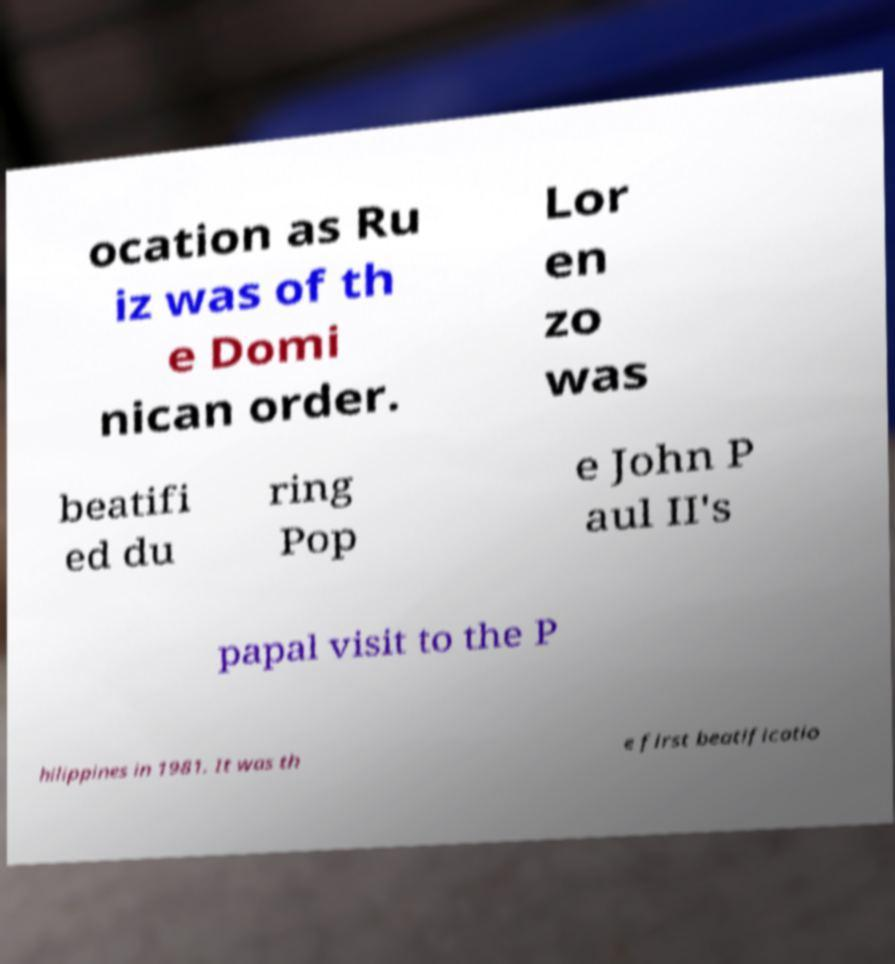I need the written content from this picture converted into text. Can you do that? ocation as Ru iz was of th e Domi nican order. Lor en zo was beatifi ed du ring Pop e John P aul II's papal visit to the P hilippines in 1981. It was th e first beatificatio 